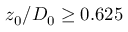<formula> <loc_0><loc_0><loc_500><loc_500>z _ { 0 } / D _ { 0 } \geq 0 . 6 2 5</formula> 